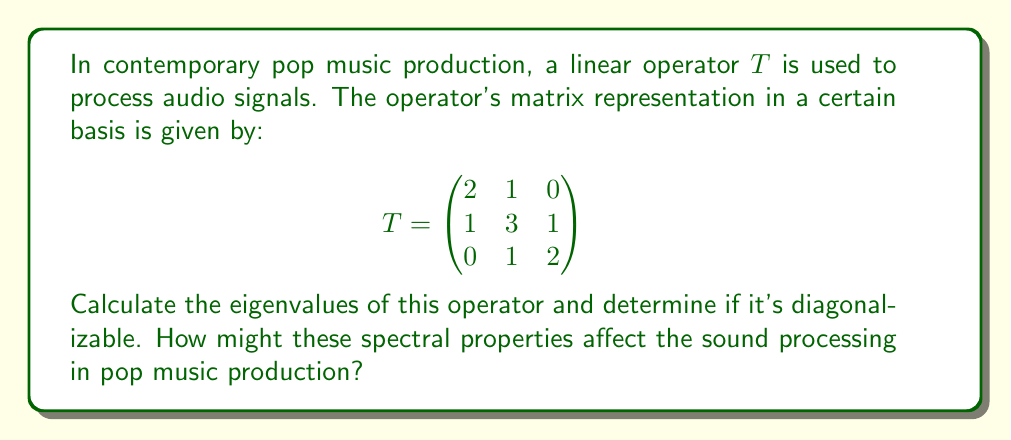Can you solve this math problem? To find the eigenvalues and determine diagonalizability, we'll follow these steps:

1) First, we need to find the characteristic polynomial of $T$:
   $p(λ) = det(T - λI)$
   
   $$det\begin{pmatrix}
   2-λ & 1 & 0 \\
   1 & 3-λ & 1 \\
   0 & 1 & 2-λ
   \end{pmatrix}$$

2) Expanding this determinant:
   $p(λ) = (2-λ)[(3-λ)(2-λ) - 1] - 1[1(2-λ) - 0]$
   $= (2-λ)(6-5λ+λ^2) - (2-λ)$
   $= 12-10λ+2λ^2-6λ+5λ^2-λ^3-2+λ$
   $= -λ^3+7λ^2-11λ+10$
   $= -(λ-1)(λ-2)(λ-4)$

3) The roots of this polynomial are the eigenvalues:
   $λ_1 = 1, λ_2 = 2, λ_3 = 4$

4) To determine if $T$ is diagonalizable, we need to check if there are enough linearly independent eigenvectors. A 3x3 matrix is diagonalizable if and only if it has 3 linearly independent eigenvectors.

5) For $λ_1 = 1$:
   $(T-I)v = 0$
   $$\begin{pmatrix}
   1 & 1 & 0 \\
   1 & 2 & 1 \\
   0 & 1 & 1
   \end{pmatrix}v = 0$$
   This gives us the eigenvector $v_1 = (1, -1, 1)^T$

6) For $λ_2 = 2$:
   $(T-2I)v = 0$
   $$\begin{pmatrix}
   0 & 1 & 0 \\
   1 & 1 & 1 \\
   0 & 1 & 0
   \end{pmatrix}v = 0$$
   This gives us the eigenvector $v_2 = (1, 0, -1)^T$

7) For $λ_3 = 4$:
   $(T-4I)v = 0$
   $$\begin{pmatrix}
   -2 & 1 & 0 \\
   1 & -1 & 1 \\
   0 & 1 & -2
   \end{pmatrix}v = 0$$
   This gives us the eigenvector $v_3 = (1, 2, 1)^T$

8) These three eigenvectors are linearly independent, so $T$ is diagonalizable.

In pop music production, these spectral properties could affect sound processing in several ways:

- The eigenvalues represent the scaling factors applied to different components of the sound.
- The fact that the operator is diagonalizable means it can be decomposed into simpler transformations, which could allow for more efficient processing or easier adjustment of specific sound components.
- The largest eigenvalue (4) might correspond to a frequency range that gets amplified the most, potentially emphasizing certain tones in the music.
Answer: The eigenvalues of the operator are 1, 2, and 4. The operator is diagonalizable because it has three linearly independent eigenvectors. 